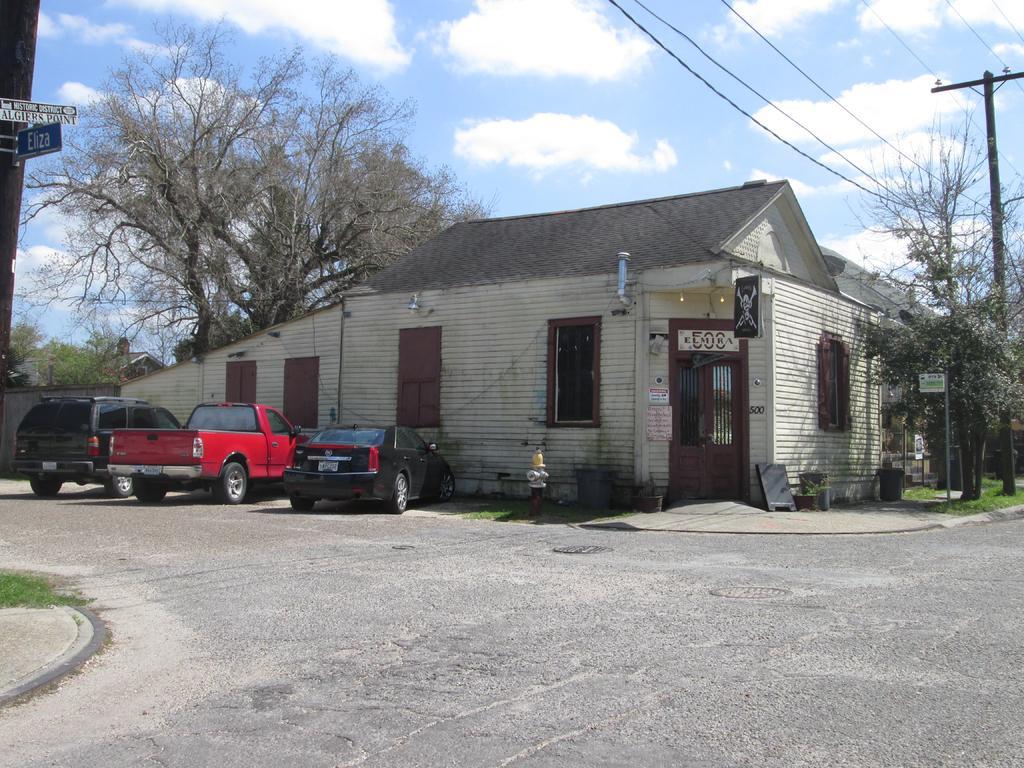How would you summarize this image in a sentence or two? We can see boards on poles and we can see vehicles parking on the road. We can see pole with wires,grass and house. Background we can see trees and sky is cloudy. 